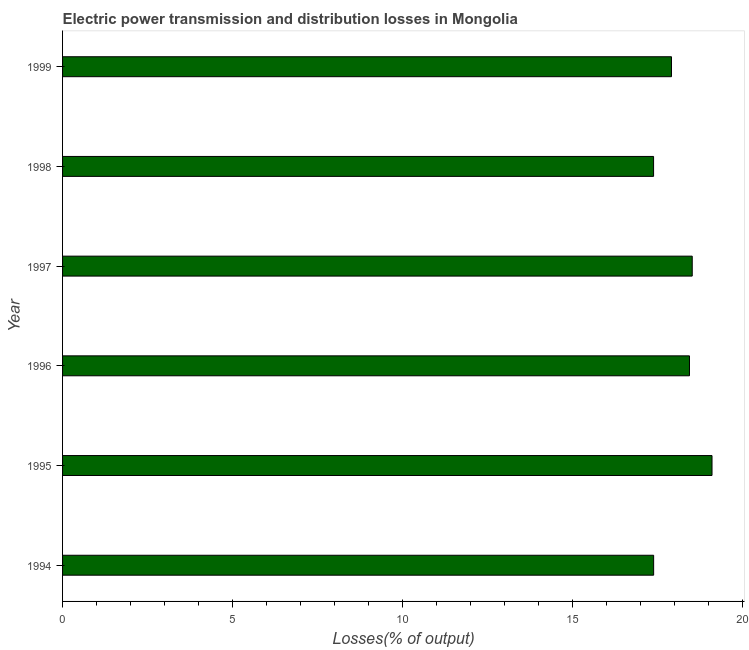Does the graph contain any zero values?
Give a very brief answer. No. What is the title of the graph?
Your response must be concise. Electric power transmission and distribution losses in Mongolia. What is the label or title of the X-axis?
Your answer should be compact. Losses(% of output). What is the electric power transmission and distribution losses in 1995?
Give a very brief answer. 19.1. Across all years, what is the maximum electric power transmission and distribution losses?
Provide a short and direct response. 19.1. Across all years, what is the minimum electric power transmission and distribution losses?
Your answer should be compact. 17.38. In which year was the electric power transmission and distribution losses maximum?
Offer a terse response. 1995. In which year was the electric power transmission and distribution losses minimum?
Provide a short and direct response. 1998. What is the sum of the electric power transmission and distribution losses?
Keep it short and to the point. 108.74. What is the difference between the electric power transmission and distribution losses in 1994 and 1997?
Provide a succinct answer. -1.14. What is the average electric power transmission and distribution losses per year?
Provide a succinct answer. 18.12. What is the median electric power transmission and distribution losses?
Keep it short and to the point. 18.17. Do a majority of the years between 1995 and 1997 (inclusive) have electric power transmission and distribution losses greater than 7 %?
Offer a very short reply. Yes. What is the ratio of the electric power transmission and distribution losses in 1994 to that in 1996?
Make the answer very short. 0.94. What is the difference between the highest and the second highest electric power transmission and distribution losses?
Provide a short and direct response. 0.58. Is the sum of the electric power transmission and distribution losses in 1997 and 1999 greater than the maximum electric power transmission and distribution losses across all years?
Give a very brief answer. Yes. What is the difference between the highest and the lowest electric power transmission and distribution losses?
Offer a very short reply. 1.72. How many bars are there?
Your answer should be very brief. 6. What is the difference between two consecutive major ticks on the X-axis?
Give a very brief answer. 5. What is the Losses(% of output) of 1994?
Give a very brief answer. 17.38. What is the Losses(% of output) in 1995?
Provide a short and direct response. 19.1. What is the Losses(% of output) of 1996?
Provide a succinct answer. 18.44. What is the Losses(% of output) in 1997?
Give a very brief answer. 18.52. What is the Losses(% of output) of 1998?
Your response must be concise. 17.38. What is the Losses(% of output) of 1999?
Provide a short and direct response. 17.91. What is the difference between the Losses(% of output) in 1994 and 1995?
Your response must be concise. -1.72. What is the difference between the Losses(% of output) in 1994 and 1996?
Offer a very short reply. -1.05. What is the difference between the Losses(% of output) in 1994 and 1997?
Ensure brevity in your answer.  -1.14. What is the difference between the Losses(% of output) in 1994 and 1998?
Provide a short and direct response. 0. What is the difference between the Losses(% of output) in 1994 and 1999?
Give a very brief answer. -0.53. What is the difference between the Losses(% of output) in 1995 and 1996?
Provide a short and direct response. 0.66. What is the difference between the Losses(% of output) in 1995 and 1997?
Your response must be concise. 0.58. What is the difference between the Losses(% of output) in 1995 and 1998?
Your response must be concise. 1.72. What is the difference between the Losses(% of output) in 1995 and 1999?
Your answer should be very brief. 1.19. What is the difference between the Losses(% of output) in 1996 and 1997?
Give a very brief answer. -0.08. What is the difference between the Losses(% of output) in 1996 and 1998?
Offer a terse response. 1.06. What is the difference between the Losses(% of output) in 1996 and 1999?
Your answer should be very brief. 0.53. What is the difference between the Losses(% of output) in 1997 and 1998?
Keep it short and to the point. 1.14. What is the difference between the Losses(% of output) in 1997 and 1999?
Keep it short and to the point. 0.61. What is the difference between the Losses(% of output) in 1998 and 1999?
Your answer should be very brief. -0.53. What is the ratio of the Losses(% of output) in 1994 to that in 1995?
Offer a very short reply. 0.91. What is the ratio of the Losses(% of output) in 1994 to that in 1996?
Ensure brevity in your answer.  0.94. What is the ratio of the Losses(% of output) in 1994 to that in 1997?
Offer a very short reply. 0.94. What is the ratio of the Losses(% of output) in 1995 to that in 1996?
Ensure brevity in your answer.  1.04. What is the ratio of the Losses(% of output) in 1995 to that in 1997?
Make the answer very short. 1.03. What is the ratio of the Losses(% of output) in 1995 to that in 1998?
Provide a short and direct response. 1.1. What is the ratio of the Losses(% of output) in 1995 to that in 1999?
Offer a terse response. 1.07. What is the ratio of the Losses(% of output) in 1996 to that in 1997?
Keep it short and to the point. 1. What is the ratio of the Losses(% of output) in 1996 to that in 1998?
Offer a very short reply. 1.06. What is the ratio of the Losses(% of output) in 1996 to that in 1999?
Keep it short and to the point. 1.03. What is the ratio of the Losses(% of output) in 1997 to that in 1998?
Your answer should be compact. 1.06. What is the ratio of the Losses(% of output) in 1997 to that in 1999?
Your response must be concise. 1.03. 